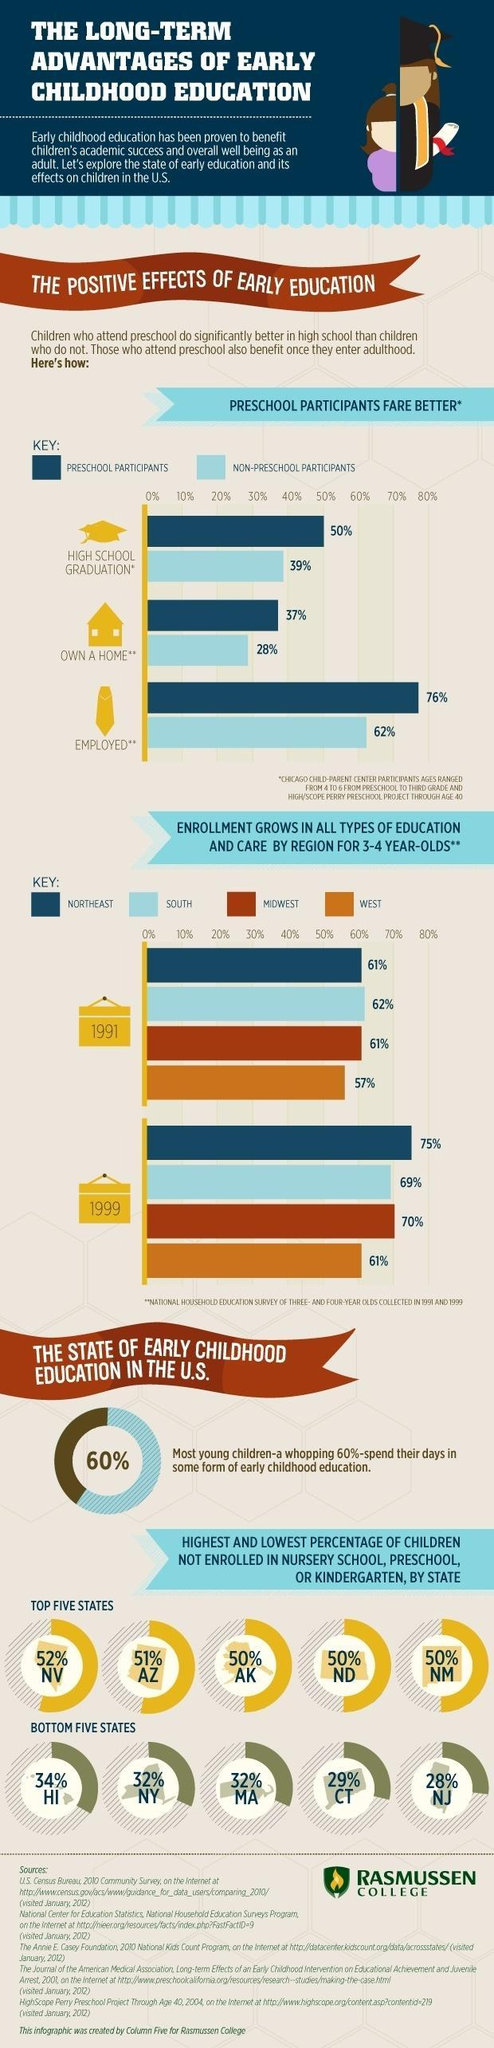What is the difference between preschool participants and non-preschool participants who are employed?
Answer the question with a short phrase. 14% Which all states have 50% of children not enrolled in nursery school, preschool, or kindergarten? AK, ND, NM What is the difference between preschool participants and non-preschool participants in high school graduation? 11% Which all states have 32% of children not enrolled in nursery school, preschool, or kindergarten? NY, MA What is the difference between preschool participants and non-preschool participants who own a home? 9% 